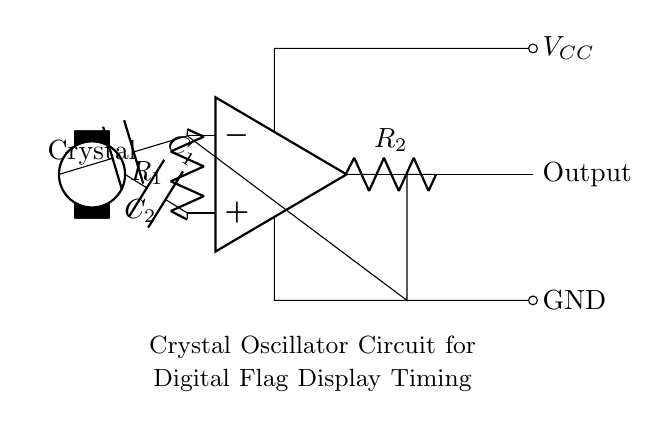What type of circuit is shown? The circuit is a crystal oscillator circuit, used for generating precise timing signals. This is identified by the presence of a crystal component which is characteristic of oscillators, along with the operational amplifier and capacitors that facilitate signal amplification and stabilization.
Answer: Crystal oscillator How many capacitors are in the circuit? There are two capacitors present in the circuit, labeled as C1 and C2. The visual representation shows one capacitor connected to the crystal and the other connected to the operational amplifier.
Answer: Two What does the output indicate in this circuit? The output in this circuit represents the oscillating signal generated by the oscillator, which will be used for providing timing signals to the digital flag display. The connection from the operational amplifier to the output node indicates that the signal is being sent out from the circuit.
Answer: Oscillating signal What is the purpose of the crystal in this circuit? The crystal serves as a frequency-determining element in the oscillator circuit, ensuring that the generated frequency is stable and precise. It resonates at a specific frequency when voltage is applied, allowing for accurate timing necessary for the digital flag display.
Answer: Frequency-determining element What is the role of the resistor R2? Resistor R2 functions as a feedback component in the oscillator circuit, helping to control the gain of the operational amplifier, which is essential for sustaining the oscillation process, impact on stability, and determining the output signal shape.
Answer: Feedback component 